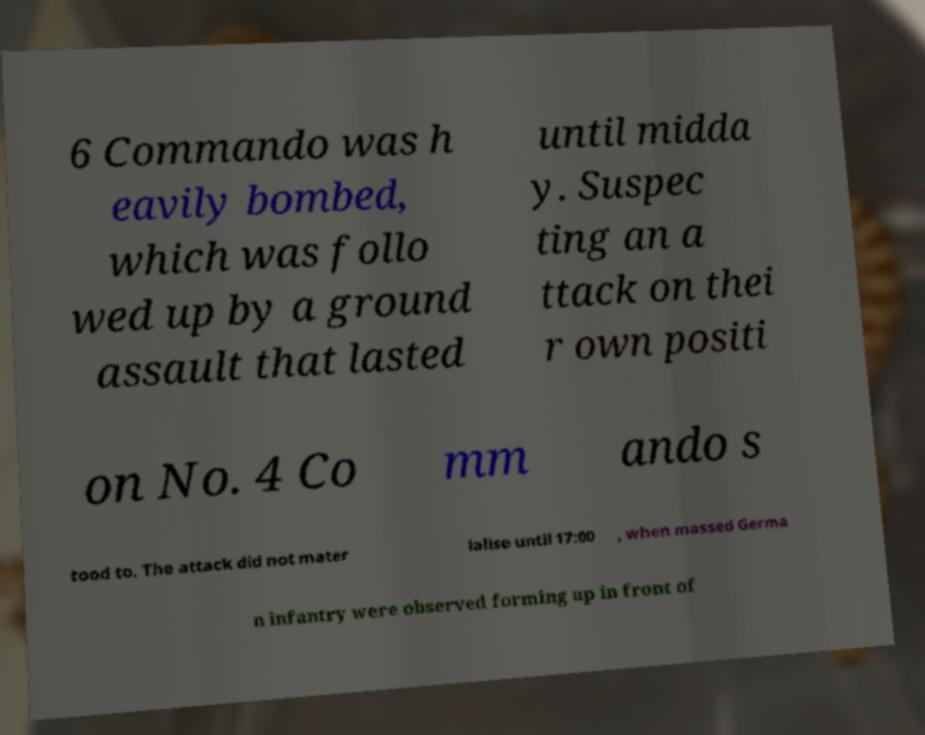Can you read and provide the text displayed in the image?This photo seems to have some interesting text. Can you extract and type it out for me? 6 Commando was h eavily bombed, which was follo wed up by a ground assault that lasted until midda y. Suspec ting an a ttack on thei r own positi on No. 4 Co mm ando s tood to. The attack did not mater ialise until 17:00 , when massed Germa n infantry were observed forming up in front of 